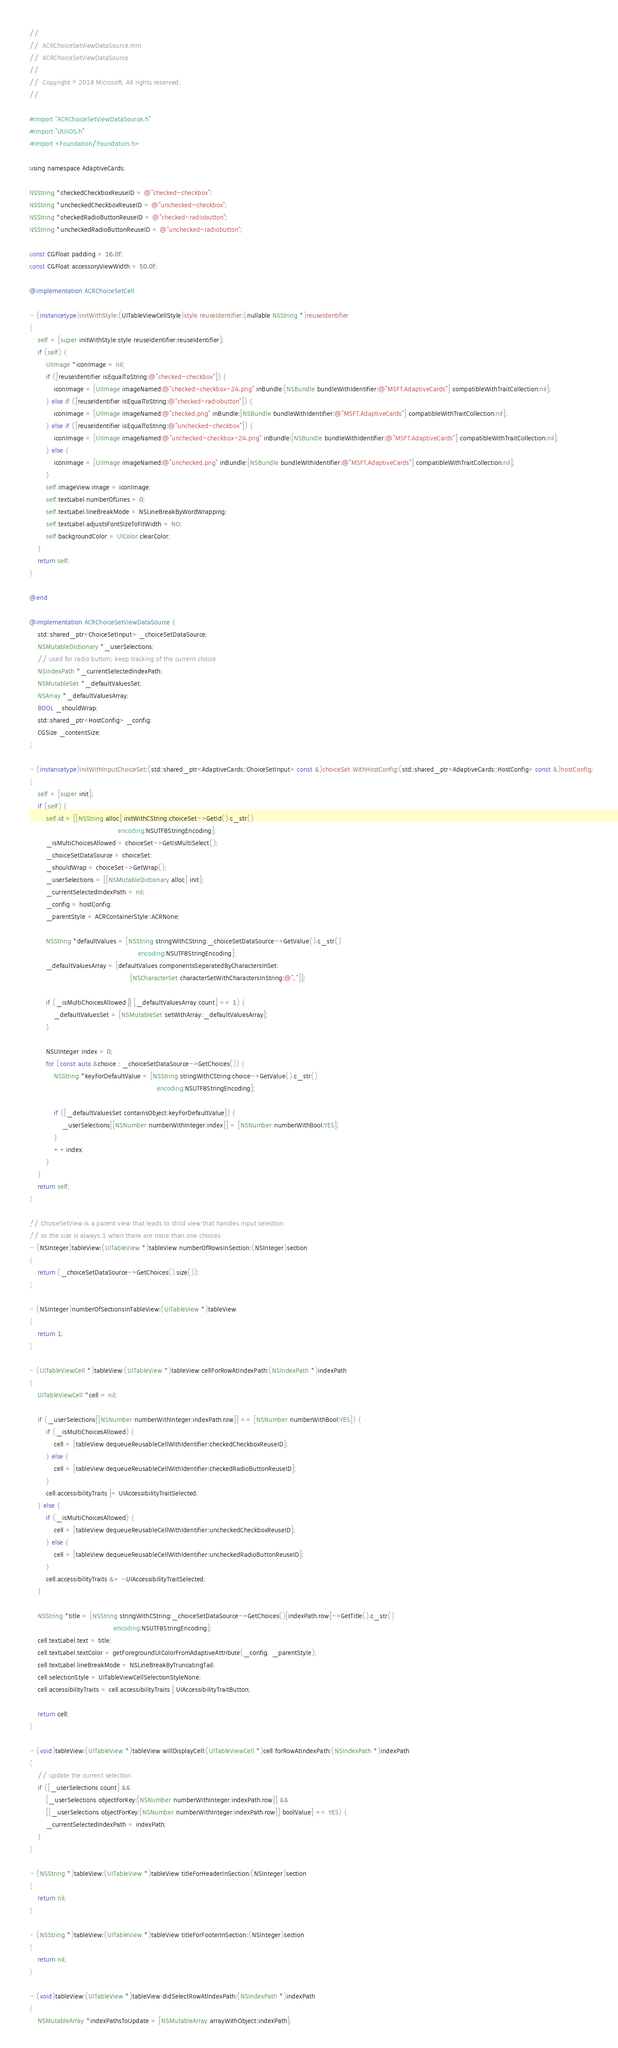Convert code to text. <code><loc_0><loc_0><loc_500><loc_500><_ObjectiveC_>//
//  ACRChoiceSetViewDataSource.mm
//  ACRChoiceSetViewDataSource
//
//  Copyright © 2018 Microsoft. All rights reserved.
//

#import "ACRChoiceSetViewDataSource.h"
#import "UtiliOS.h"
#import <Foundation/Foundation.h>

using namespace AdaptiveCards;

NSString *checkedCheckboxReuseID = @"checked-checkbox";
NSString *uncheckedCheckboxReuseID = @"unchecked-checkbox";
NSString *checkedRadioButtonReuseID = @"checked-radiobutton";
NSString *uncheckedRadioButtonReuseID = @"unchecked-radiobutton";

const CGFloat padding = 16.0f;
const CGFloat accessoryViewWidth = 50.0f;

@implementation ACRChoiceSetCell

- (instancetype)initWithStyle:(UITableViewCellStyle)style reuseIdentifier:(nullable NSString *)reuseIdentifier
{
    self = [super initWithStyle:style reuseIdentifier:reuseIdentifier];
    if (self) {
        UIImage *iconImage = nil;
        if ([reuseIdentifier isEqualToString:@"checked-checkbox"]) {
            iconImage = [UIImage imageNamed:@"checked-checkbox-24.png" inBundle:[NSBundle bundleWithIdentifier:@"MSFT.AdaptiveCards"] compatibleWithTraitCollection:nil];
        } else if ([reuseIdentifier isEqualToString:@"checked-radiobutton"]) {
            iconImage = [UIImage imageNamed:@"checked.png" inBundle:[NSBundle bundleWithIdentifier:@"MSFT.AdaptiveCards"] compatibleWithTraitCollection:nil];
        } else if ([reuseIdentifier isEqualToString:@"unchecked-checkbox"]) {
            iconImage = [UIImage imageNamed:@"unchecked-checkbox-24.png" inBundle:[NSBundle bundleWithIdentifier:@"MSFT.AdaptiveCards"] compatibleWithTraitCollection:nil];
        } else {
            iconImage = [UIImage imageNamed:@"unchecked.png" inBundle:[NSBundle bundleWithIdentifier:@"MSFT.AdaptiveCards"] compatibleWithTraitCollection:nil];
        }
        self.imageView.image = iconImage;
        self.textLabel.numberOfLines = 0;
        self.textLabel.lineBreakMode = NSLineBreakByWordWrapping;
        self.textLabel.adjustsFontSizeToFitWidth = NO;
        self.backgroundColor = UIColor.clearColor;
    }
    return self;
}

@end

@implementation ACRChoiceSetViewDataSource {
    std::shared_ptr<ChoiceSetInput> _choiceSetDataSource;
    NSMutableDictionary *_userSelections;
    // used for radio button; keep tracking of the current choice
    NSIndexPath *_currentSelectedIndexPath;
    NSMutableSet *_defaultValuesSet;
    NSArray *_defaultValuesArray;
    BOOL _shouldWrap;
    std::shared_ptr<HostConfig> _config;
    CGSize _contentSize;
}

- (instancetype)initWithInputChoiceSet:(std::shared_ptr<AdaptiveCards::ChoiceSetInput> const &)choiceSet WithHostConfig:(std::shared_ptr<AdaptiveCards::HostConfig> const &)hostConfig;
{
    self = [super init];
    if (self) {
        self.id = [[NSString alloc] initWithCString:choiceSet->GetId().c_str()
                                           encoding:NSUTF8StringEncoding];
        _isMultiChoicesAllowed = choiceSet->GetIsMultiSelect();
        _choiceSetDataSource = choiceSet;
        _shouldWrap = choiceSet->GetWrap();
        _userSelections = [[NSMutableDictionary alloc] init];
        _currentSelectedIndexPath = nil;
        _config = hostConfig;
        _parentStyle = ACRContainerStyle::ACRNone;

        NSString *defaultValues = [NSString stringWithCString:_choiceSetDataSource->GetValue().c_str()
                                                     encoding:NSUTF8StringEncoding];
        _defaultValuesArray = [defaultValues componentsSeparatedByCharactersInSet:
                                                 [NSCharacterSet characterSetWithCharactersInString:@","]];

        if (_isMultiChoicesAllowed || [_defaultValuesArray count] == 1) {
            _defaultValuesSet = [NSMutableSet setWithArray:_defaultValuesArray];
        }

        NSUInteger index = 0;
        for (const auto &choice : _choiceSetDataSource->GetChoices()) {
            NSString *keyForDefaultValue = [NSString stringWithCString:choice->GetValue().c_str()
                                                              encoding:NSUTF8StringEncoding];

            if ([_defaultValuesSet containsObject:keyForDefaultValue]) {
                _userSelections[[NSNumber numberWithInteger:index]] = [NSNumber numberWithBool:YES];
            }
            ++index;
        }
    }
    return self;
}

// ChoiceSetView is a parent view that leads to child view that handles input selection
// so the size is always 1 when there are more than one choices
- (NSInteger)tableView:(UITableView *)tableView numberOfRowsInSection:(NSInteger)section
{
    return (_choiceSetDataSource->GetChoices().size());
}

- (NSInteger)numberOfSectionsInTableView:(UITableView *)tableView
{
    return 1;
}

- (UITableViewCell *)tableView:(UITableView *)tableView cellForRowAtIndexPath:(NSIndexPath *)indexPath
{
    UITableViewCell *cell = nil;

    if (_userSelections[[NSNumber numberWithInteger:indexPath.row]] == [NSNumber numberWithBool:YES]) {
        if (_isMultiChoicesAllowed) {
            cell = [tableView dequeueReusableCellWithIdentifier:checkedCheckboxReuseID];
        } else {
            cell = [tableView dequeueReusableCellWithIdentifier:checkedRadioButtonReuseID];
        }
        cell.accessibilityTraits |= UIAccessibilityTraitSelected;
    } else {
        if (_isMultiChoicesAllowed) {
            cell = [tableView dequeueReusableCellWithIdentifier:uncheckedCheckboxReuseID];
        } else {
            cell = [tableView dequeueReusableCellWithIdentifier:uncheckedRadioButtonReuseID];
        }
        cell.accessibilityTraits &= ~UIAccessibilityTraitSelected;
    }

    NSString *title = [NSString stringWithCString:_choiceSetDataSource->GetChoices()[indexPath.row]->GetTitle().c_str()
                                         encoding:NSUTF8StringEncoding];
    cell.textLabel.text = title;
    cell.textLabel.textColor = getForegroundUIColorFromAdaptiveAttribute(_config, _parentStyle);
    cell.textLabel.lineBreakMode = NSLineBreakByTruncatingTail;
    cell.selectionStyle = UITableViewCellSelectionStyleNone;
    cell.accessibilityTraits = cell.accessibilityTraits | UIAccessibilityTraitButton;

    return cell;
}

- (void)tableView:(UITableView *)tableView willDisplayCell:(UITableViewCell *)cell forRowAtIndexPath:(NSIndexPath *)indexPath
{
    // update the current selection
    if ([_userSelections count] &&
        [_userSelections objectForKey:[NSNumber numberWithInteger:indexPath.row]] &&
        [[_userSelections objectForKey:[NSNumber numberWithInteger:indexPath.row]] boolValue] == YES) {
        _currentSelectedIndexPath = indexPath;
    }
}

- (NSString *)tableView:(UITableView *)tableView titleForHeaderInSection:(NSInteger)section
{
    return nil;
}

- (NSString *)tableView:(UITableView *)tableView titleForFooterInSection:(NSInteger)section
{
    return nil;
}

- (void)tableView:(UITableView *)tableView didSelectRowAtIndexPath:(NSIndexPath *)indexPath
{
    NSMutableArray *indexPathsToUpdate = [NSMutableArray arrayWithObject:indexPath];</code> 